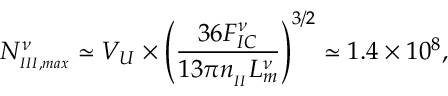<formula> <loc_0><loc_0><loc_500><loc_500>N _ { _ { I I I , \max } } ^ { \nu } \simeq V _ { U } \times \left ( \frac { 3 6 F _ { I C } ^ { \nu } } { 1 3 \pi n _ { _ { I I } } L _ { m } ^ { \nu } } \right ) ^ { 3 / 2 } \simeq 1 . 4 \times 1 0 ^ { 8 } ,</formula> 